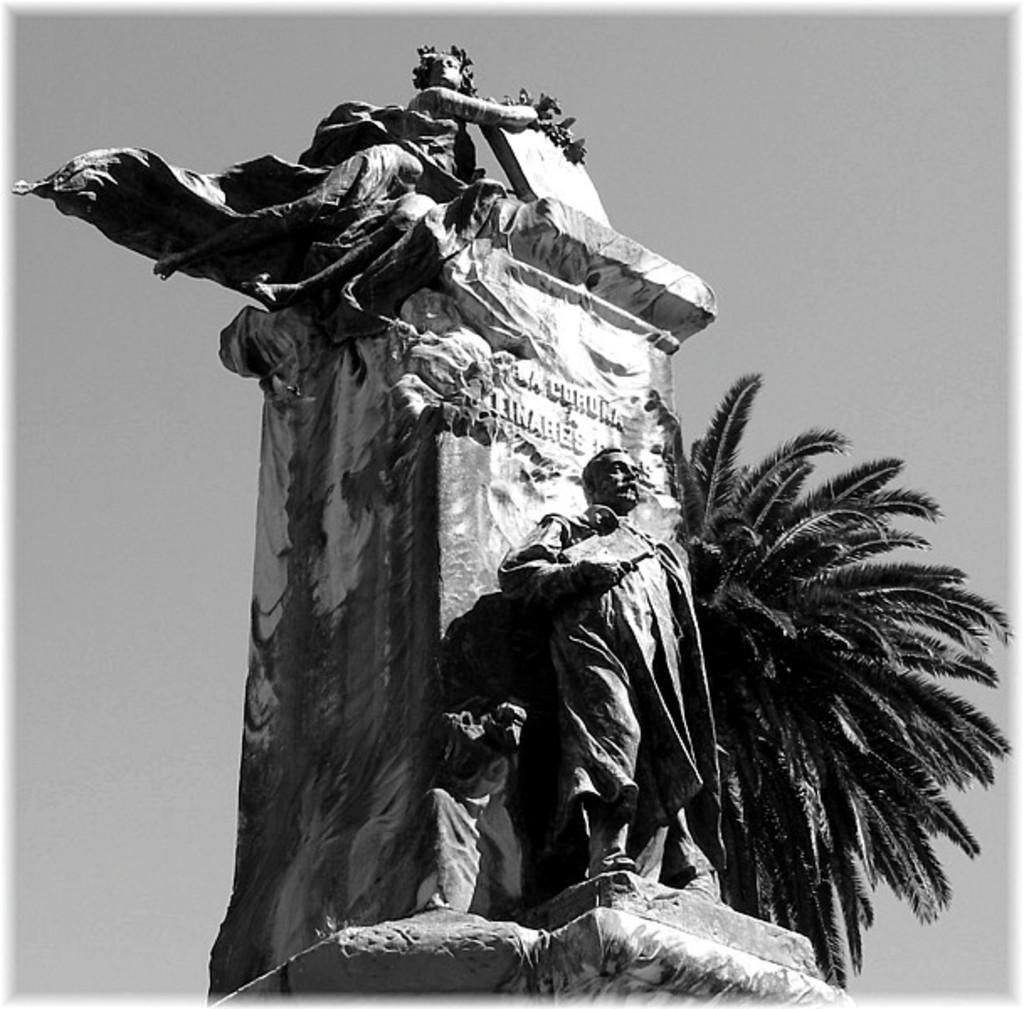What is the color scheme of the image? The image is black and white. What is the main subject in the image? There is a statue in the image. What other object can be seen in the image? There is a tree in the image. What is visible in the background of the image? The sky is visible in the background of the image. What type of competition is taking place in the image? There is no competition present in the image; it features a statue, a tree, and the sky. Can you tell me where the stove is located in the image? There is no stove present in the image. 